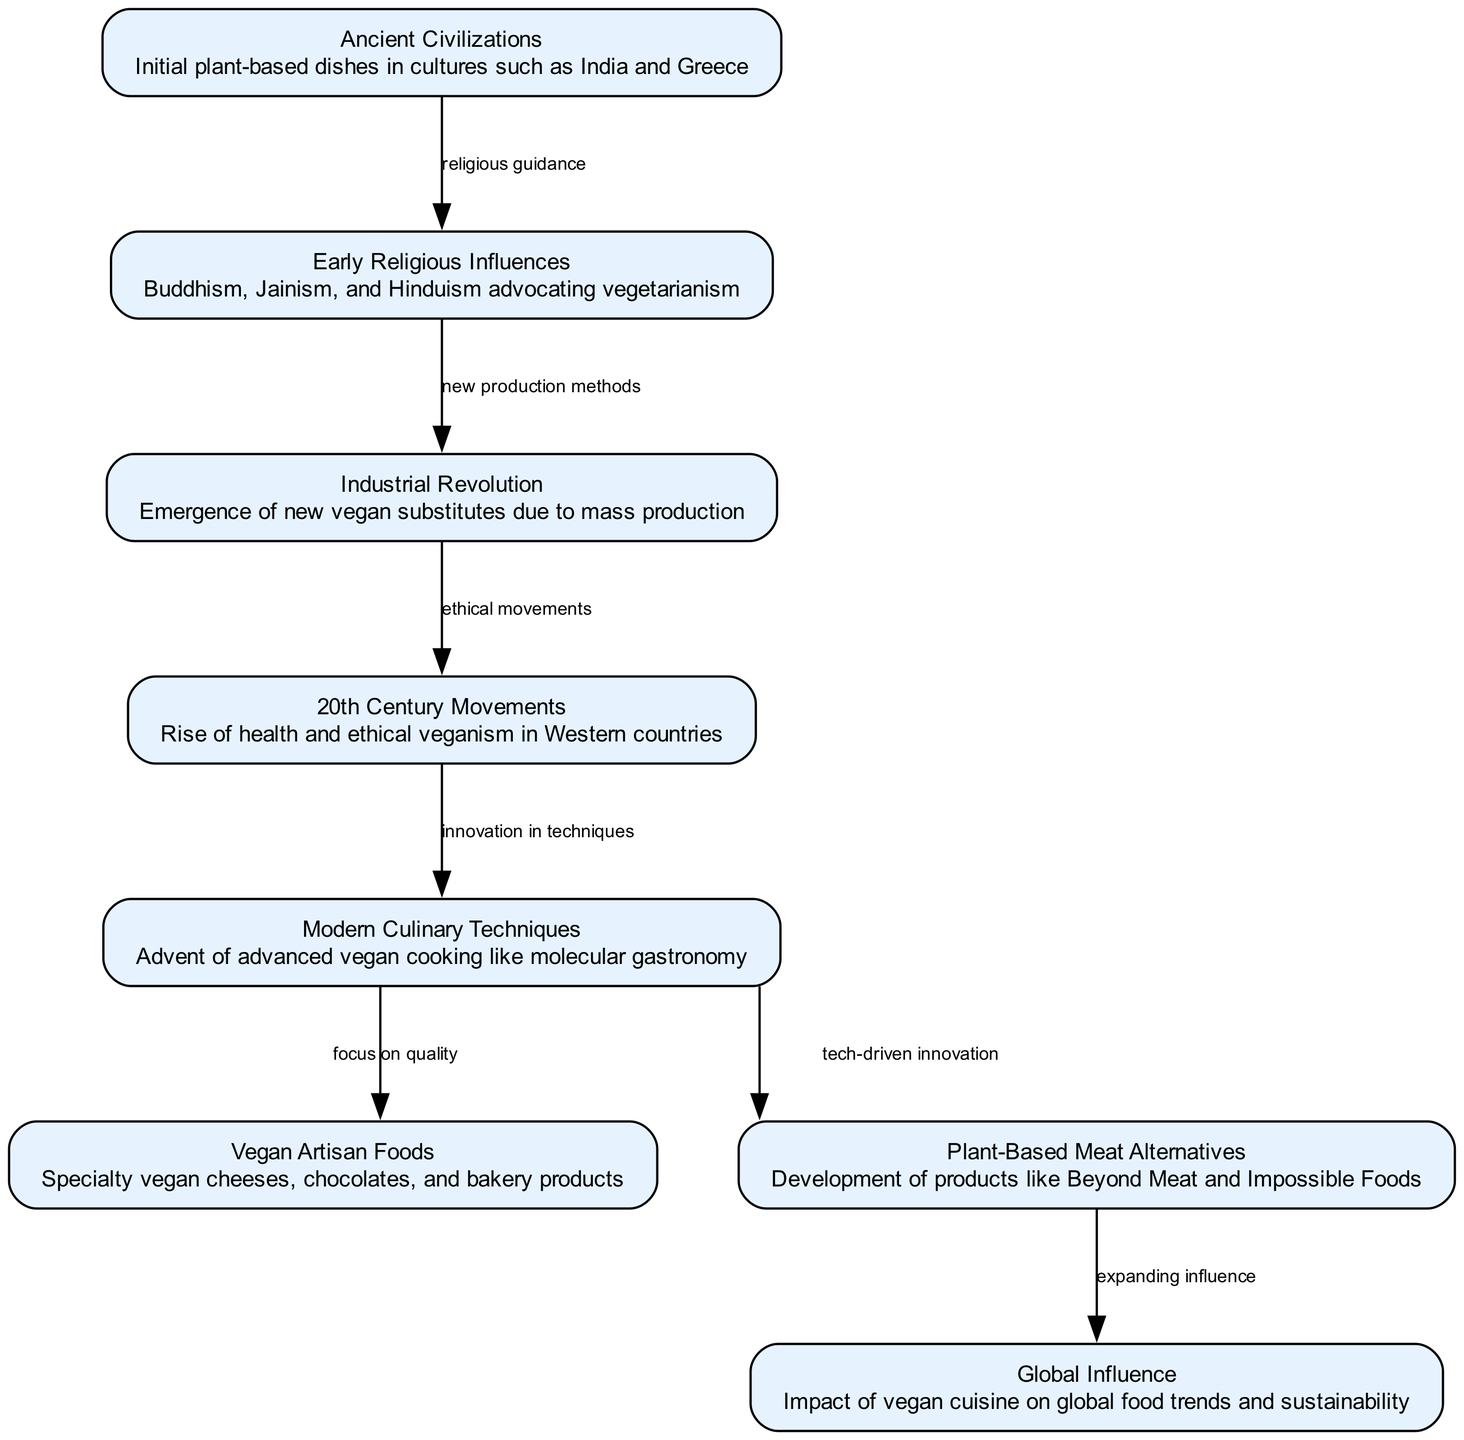What is the first node in the diagram? The first node is labeled "Ancient Civilizations," which is the starting point of the evolution discussed in the diagram.
Answer: Ancient Civilizations How many nodes are present in the diagram? The diagram lists a total of 8 distinct nodes representing various stages in the evolution of vegan culinary techniques.
Answer: 8 What relationship does the "Early Religious Influences" node have with "Ancient Civilizations"? The relationship is described as "religious guidance," indicating that early religious movements influenced the development of plant-based dishes in ancient cultures.
Answer: religious guidance What does the "Industrial Revolution" lead to in the timeline? It leads to the "20th Century Movements," suggesting that the new production methods introduced during the Industrial Revolution had an ethical impact on veganism in the 20th century.
Answer: 20th Century Movements What is a modern culinary technique mentioned in the diagram? The diagram highlights "molecular gastronomy," indicating it is a contemporary method used in vegan cooking that combines science with culinary art.
Answer: molecular gastronomy Which node focuses on quality in vegan food production? The node labeled "Vegan Artisan Foods" emphasizes a focus on quality within specialty vegan products such as cheeses and chocolates.
Answer: Vegan Artisan Foods How do "Plant-Based Meat Alternatives" affect global food trends? The diagram indicates that these alternatives have an "expanding influence" on global cuisine, showcasing their role in shaping food trends and promoting sustainability.
Answer: expanding influence What does the arrow from "Modern Culinary Techniques" to "Vegan Artisan Foods" emphasize? The arrow emphasizes a connection where innovation in culinary techniques brings a concentrated focus on quality in artisanal vegan food production.
Answer: focus on quality What common theme links "20th Century Movements" to "Modern Culinary Techniques"? The common theme is "innovation in techniques," indicating that the ethical movements sparked new advancements in culinary practices.
Answer: innovation in techniques 